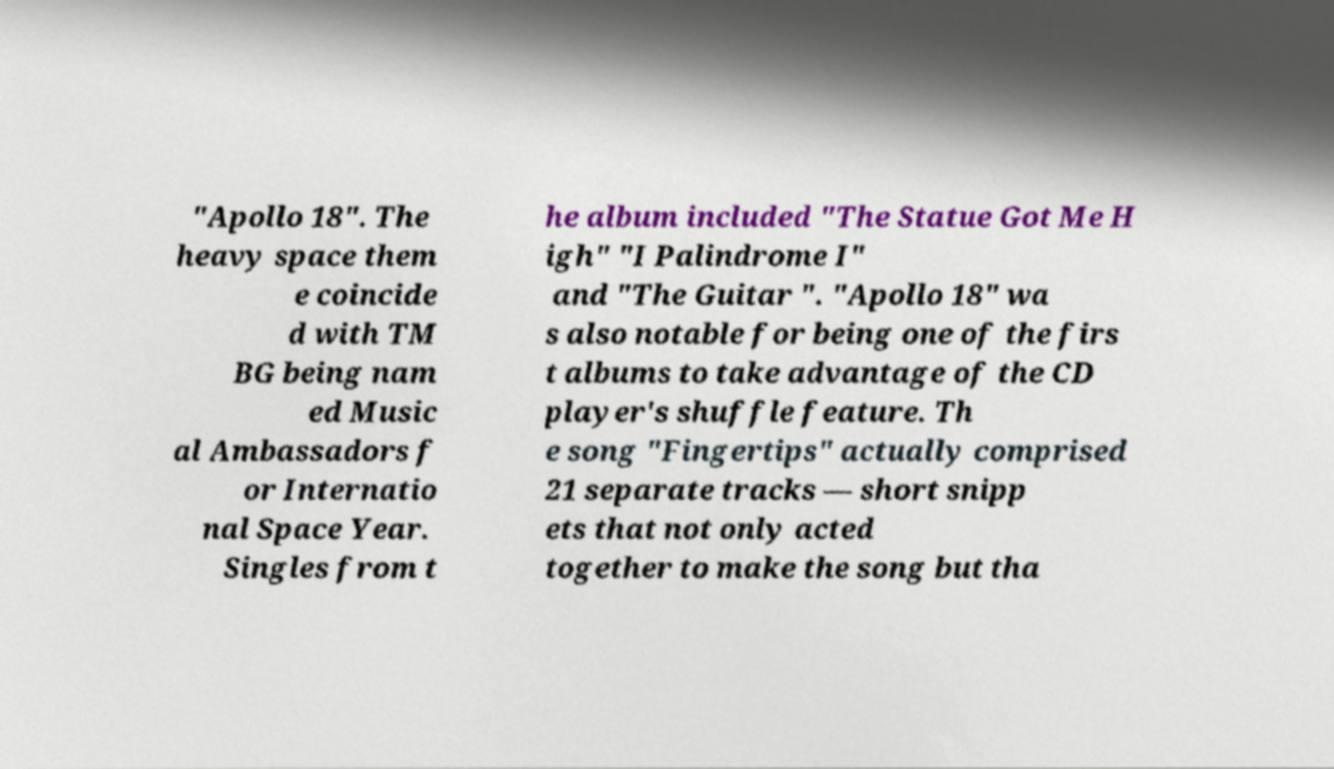Could you assist in decoding the text presented in this image and type it out clearly? "Apollo 18". The heavy space them e coincide d with TM BG being nam ed Music al Ambassadors f or Internatio nal Space Year. Singles from t he album included "The Statue Got Me H igh" "I Palindrome I" and "The Guitar ". "Apollo 18" wa s also notable for being one of the firs t albums to take advantage of the CD player's shuffle feature. Th e song "Fingertips" actually comprised 21 separate tracks — short snipp ets that not only acted together to make the song but tha 